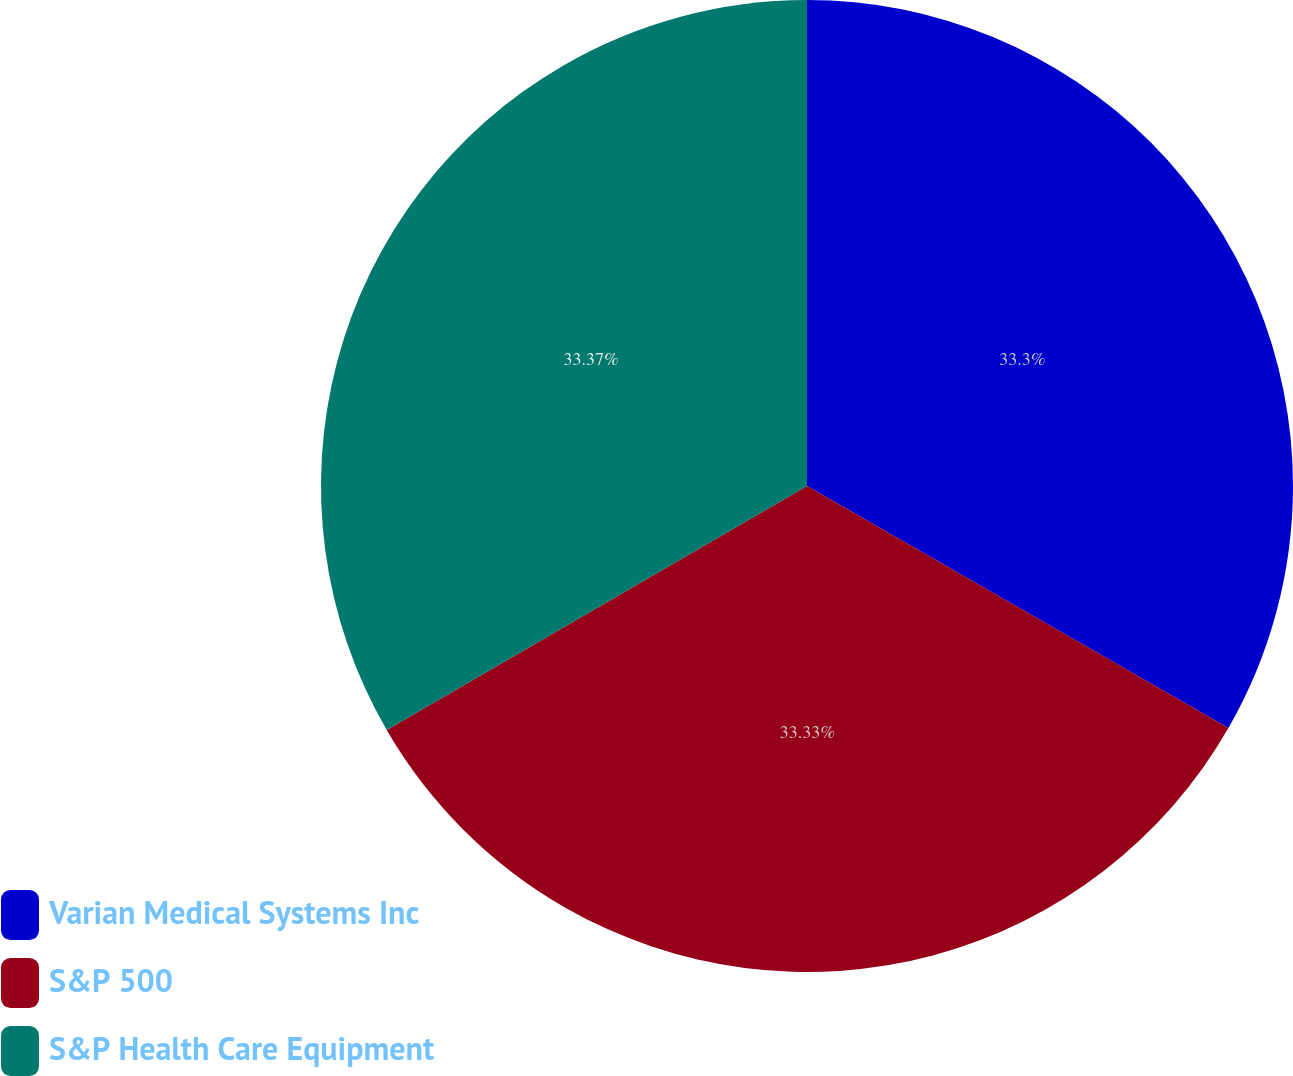Convert chart to OTSL. <chart><loc_0><loc_0><loc_500><loc_500><pie_chart><fcel>Varian Medical Systems Inc<fcel>S&P 500<fcel>S&P Health Care Equipment<nl><fcel>33.3%<fcel>33.33%<fcel>33.37%<nl></chart> 